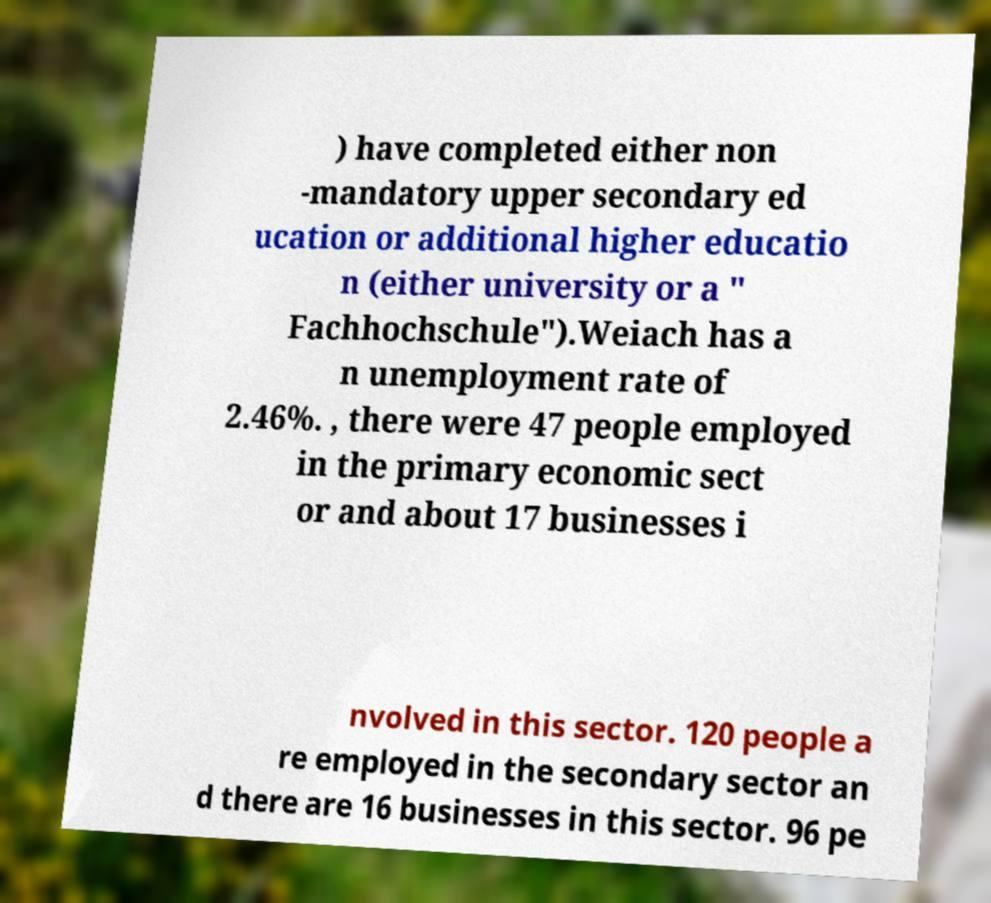Please identify and transcribe the text found in this image. ) have completed either non -mandatory upper secondary ed ucation or additional higher educatio n (either university or a " Fachhochschule").Weiach has a n unemployment rate of 2.46%. , there were 47 people employed in the primary economic sect or and about 17 businesses i nvolved in this sector. 120 people a re employed in the secondary sector an d there are 16 businesses in this sector. 96 pe 